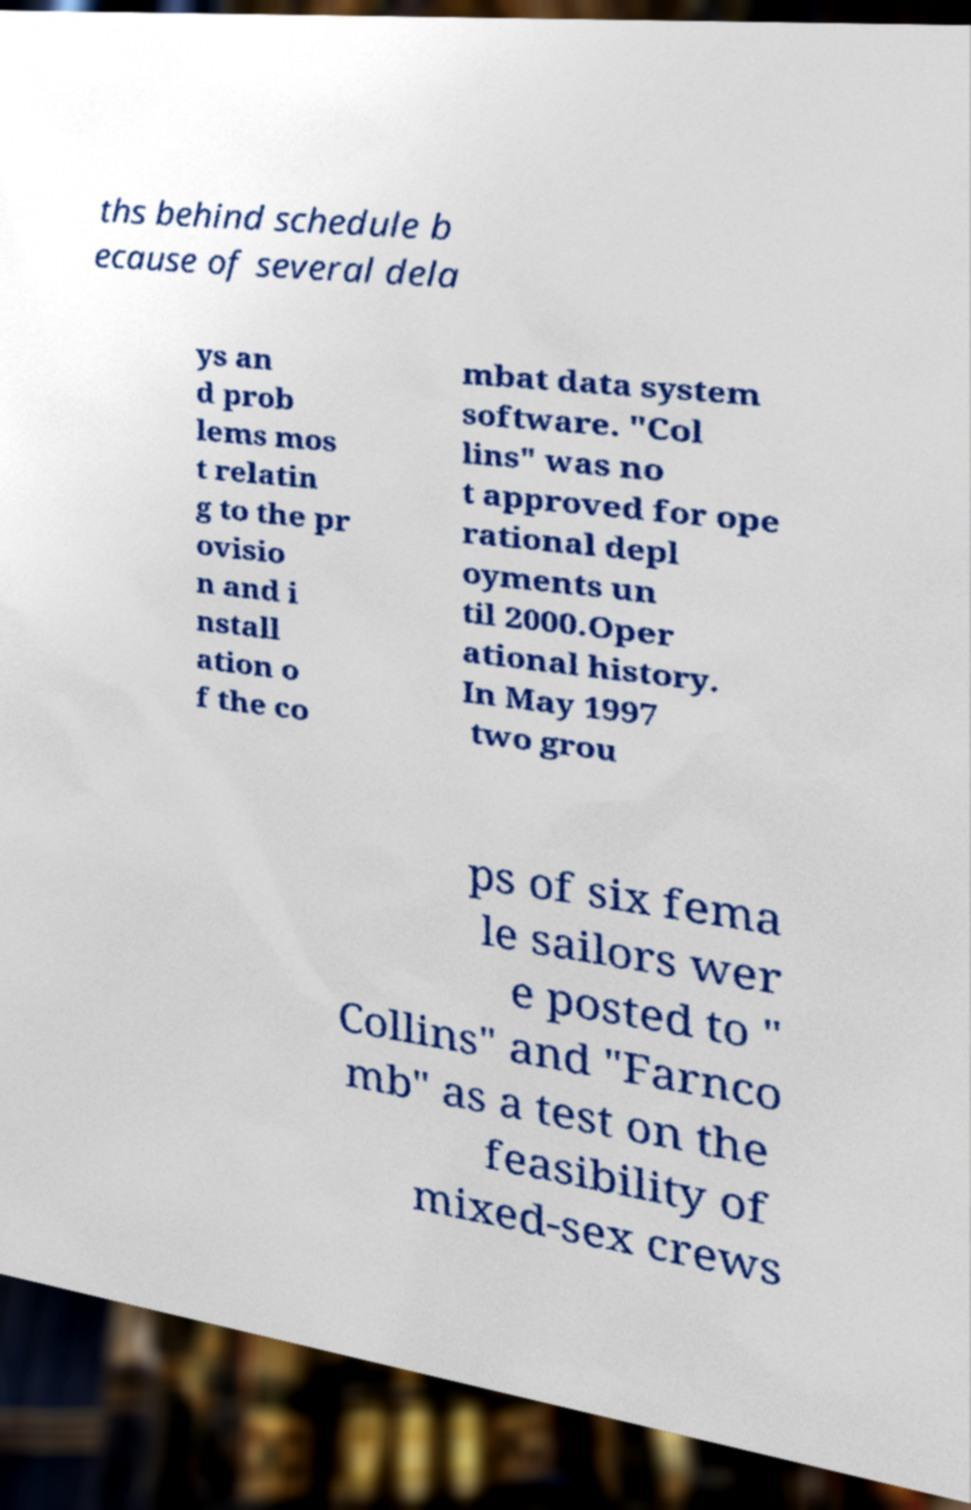I need the written content from this picture converted into text. Can you do that? ths behind schedule b ecause of several dela ys an d prob lems mos t relatin g to the pr ovisio n and i nstall ation o f the co mbat data system software. "Col lins" was no t approved for ope rational depl oyments un til 2000.Oper ational history. In May 1997 two grou ps of six fema le sailors wer e posted to " Collins" and "Farnco mb" as a test on the feasibility of mixed-sex crews 